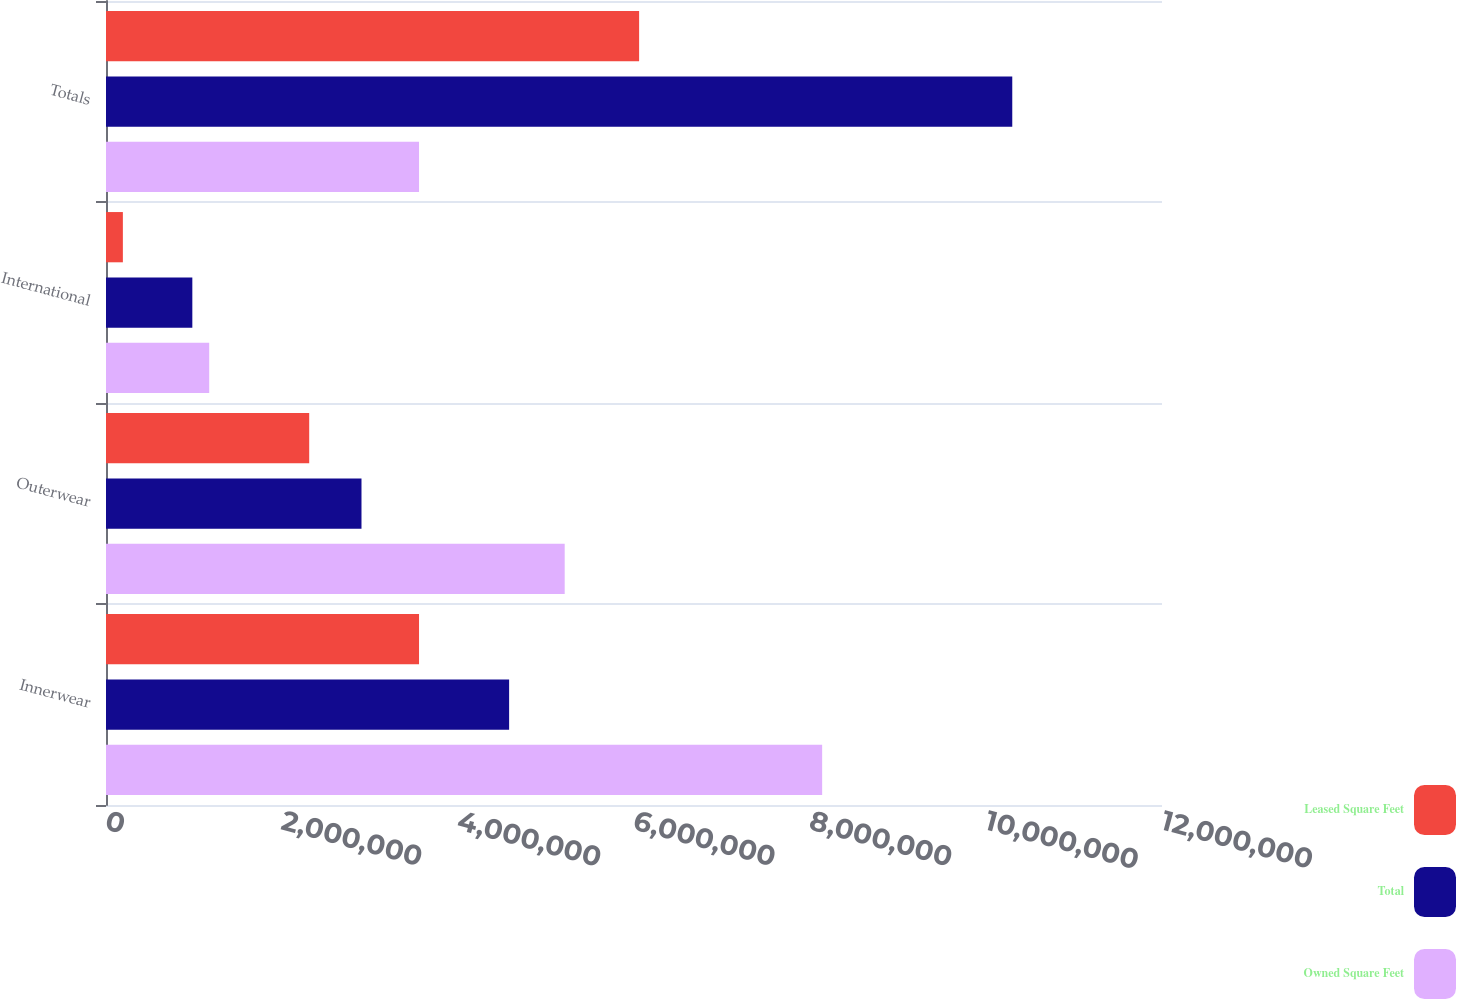Convert chart to OTSL. <chart><loc_0><loc_0><loc_500><loc_500><stacked_bar_chart><ecel><fcel>Innerwear<fcel>Outerwear<fcel>International<fcel>Totals<nl><fcel>Leased Square Feet<fcel>3.55718e+06<fcel>2.30915e+06<fcel>191793<fcel>6.05813e+06<nl><fcel>Total<fcel>4.58091e+06<fcel>2.90326e+06<fcel>981014<fcel>1.02985e+07<nl><fcel>Owned Square Feet<fcel>8.1381e+06<fcel>5.21241e+06<fcel>1.17281e+06<fcel>3.55718e+06<nl></chart> 